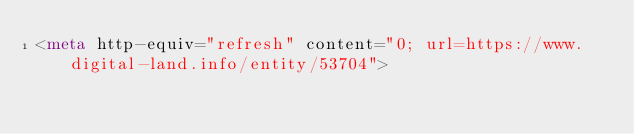Convert code to text. <code><loc_0><loc_0><loc_500><loc_500><_HTML_><meta http-equiv="refresh" content="0; url=https://www.digital-land.info/entity/53704"></code> 